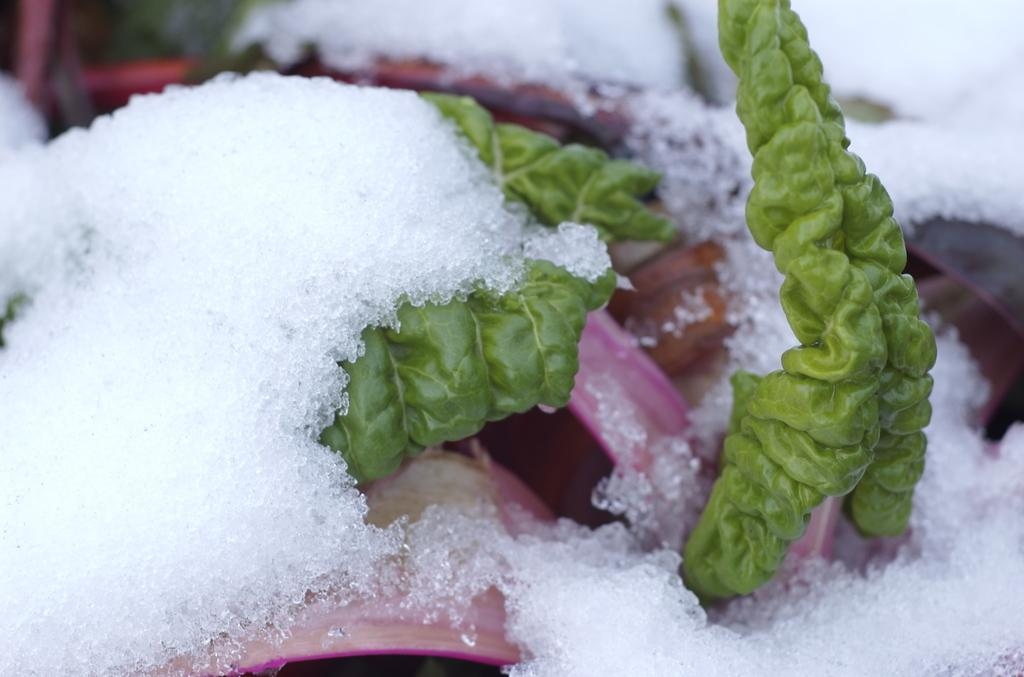What type of vegetation is present in the image? There are green leaves in the image. What is on the table in the image? There is ice on a table in the image. How much wealth does the boy have in the image? There is no boy present in the image, so it is not possible to determine his wealth. 